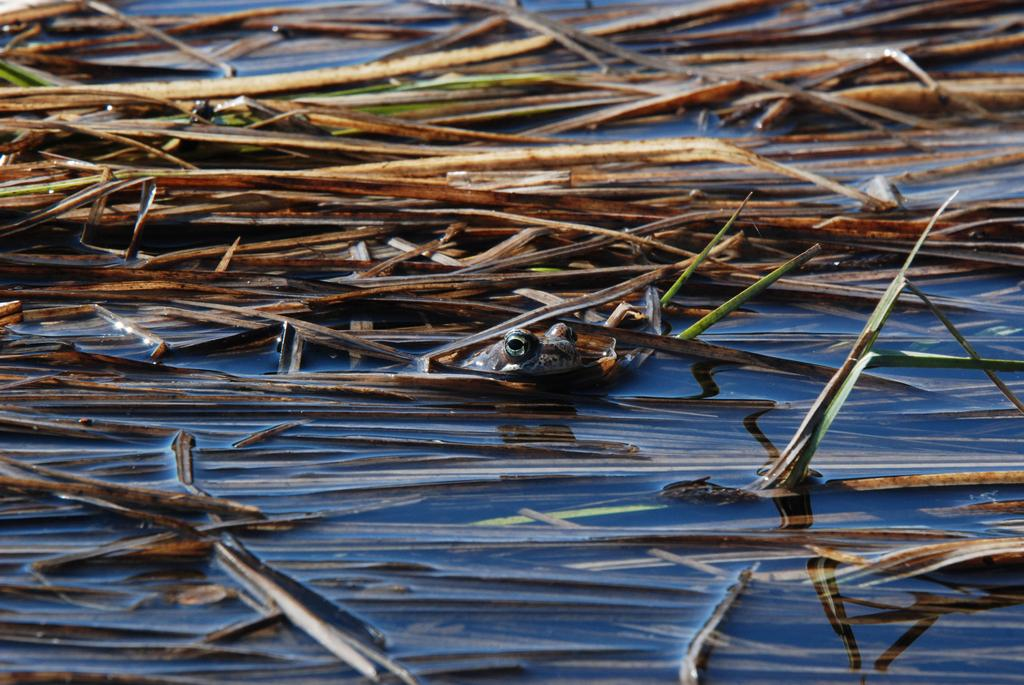What type of natural feature can be seen in the image? There is a river in the image. What type of vegetation is present in the image? Dried grass is present in the image. What type of animal can be seen in the image? There is a frog in the image. What type of harmony is being played by the writer in the image? There is no writer or harmony present in the image; it features a river, dried grass, and a frog. 